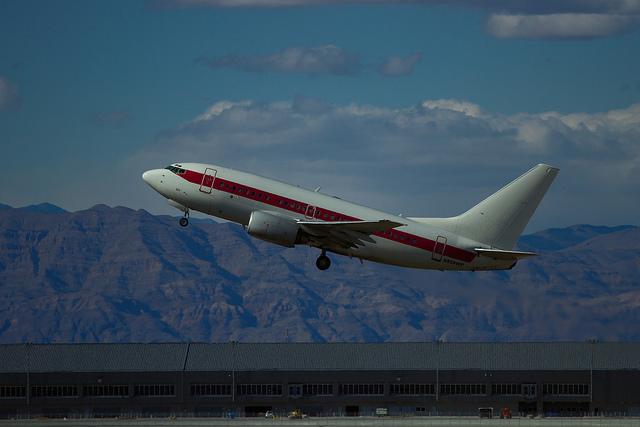Is this plane landing?
Be succinct. No. What color is the building?
Short answer required. Gray. Is the plane in the air?
Be succinct. Yes. What color is the plane?
Short answer required. White and red. What is below the plane?
Short answer required. Runway. What color is on the front of the plane?
Quick response, please. White. Which corner is the land in this picture?
Quick response, please. Right. 